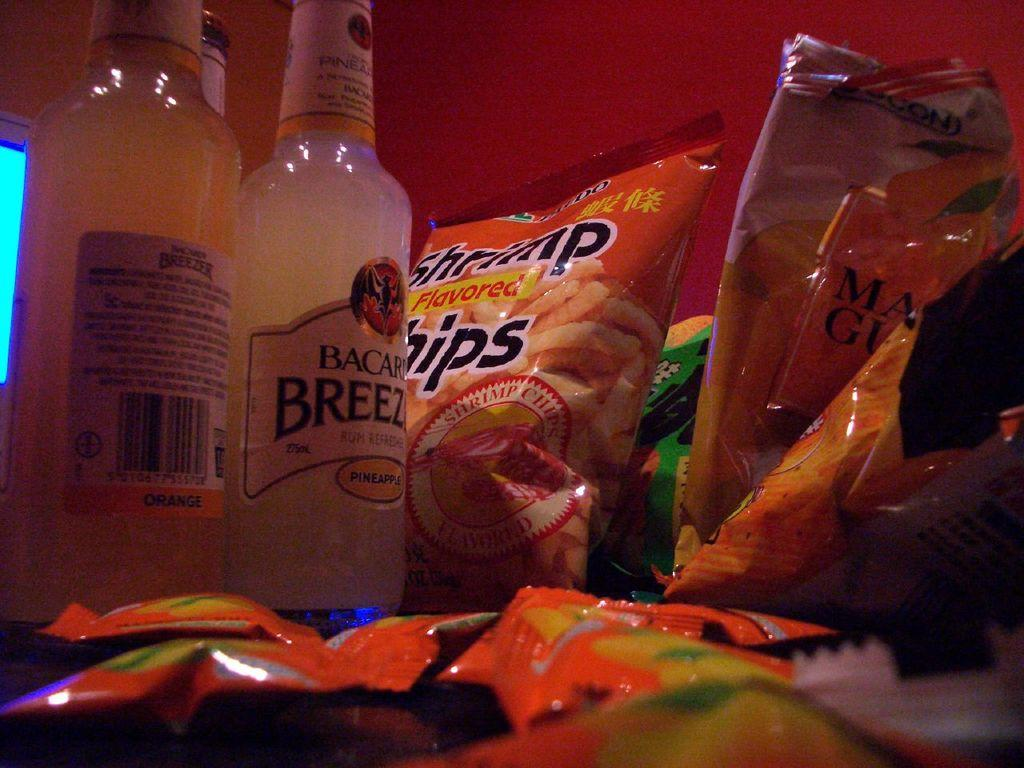How many bottles can be seen in the image? There are two bottles in the image. What else is present in the image besides the bottles? There are snack packets in the image. What is the design of the holiday title on the bottles? There is no holiday title or design present on the bottles in the image. 